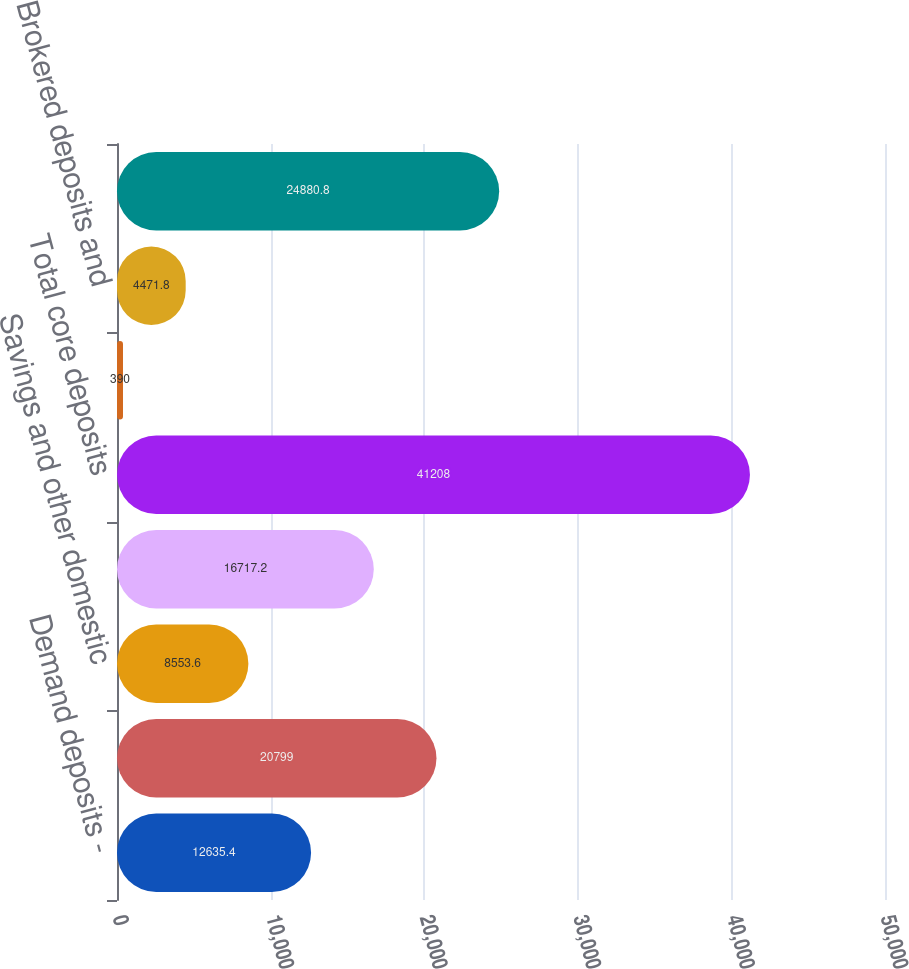Convert chart. <chart><loc_0><loc_0><loc_500><loc_500><bar_chart><fcel>Demand deposits -<fcel>Money market deposits<fcel>Savings and other domestic<fcel>Core certificates of deposit<fcel>Total core deposits<fcel>Other domestic deposits of<fcel>Brokered deposits and<fcel>Personal<nl><fcel>12635.4<fcel>20799<fcel>8553.6<fcel>16717.2<fcel>41208<fcel>390<fcel>4471.8<fcel>24880.8<nl></chart> 